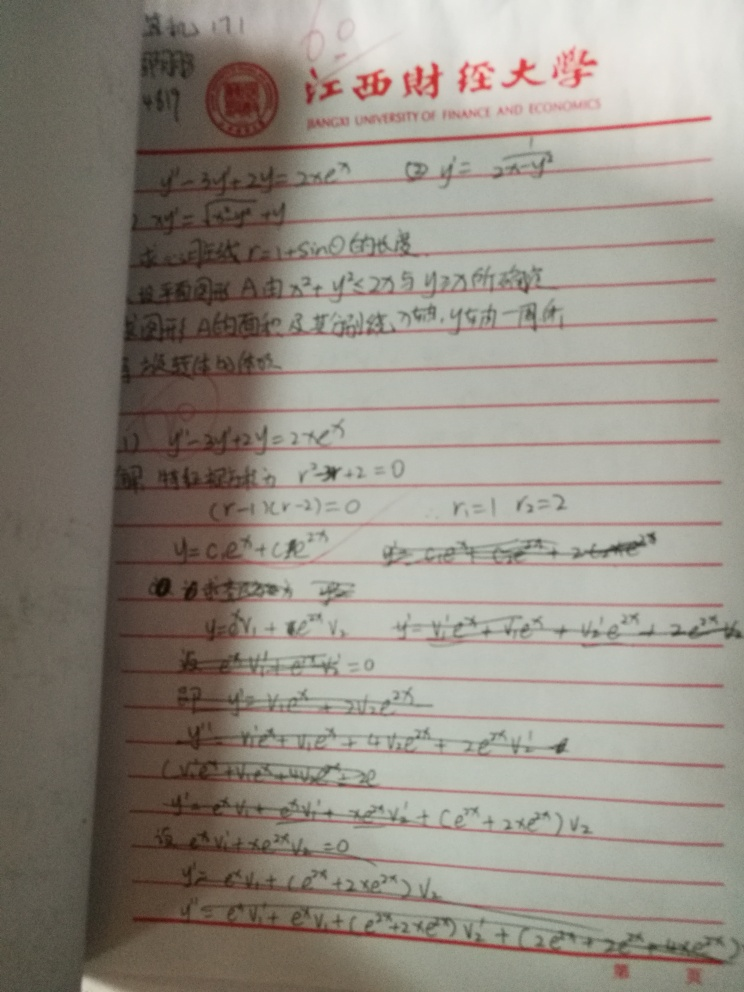What mathematical concepts are being discussed in this image? The image contains mathematical equations and solutions likely related to calculus or differential equations. It discusses concepts such as derivatives and critical points, which are fundamental in understanding changes within a function. Can you explain the significance of these concepts in practical applications? Certainly! Concepts like derivatives are crucial in fields such as physics and engineering, where they are used to model and understand phenomena like motion and heat. Understanding critical points can help in optimizing processes or finding maximum and minimum values, which are essential in economics and data analysis. 